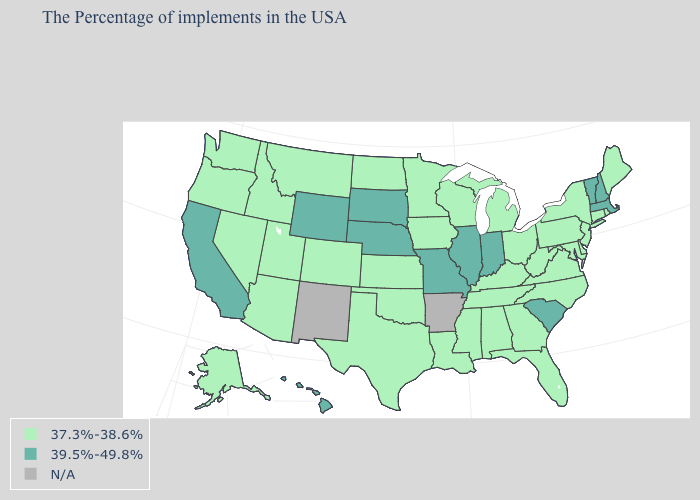Does the map have missing data?
Be succinct. Yes. Name the states that have a value in the range N/A?
Answer briefly. Arkansas, New Mexico. Among the states that border Vermont , does New Hampshire have the lowest value?
Concise answer only. No. Which states have the lowest value in the USA?
Be succinct. Maine, Rhode Island, Connecticut, New York, New Jersey, Delaware, Maryland, Pennsylvania, Virginia, North Carolina, West Virginia, Ohio, Florida, Georgia, Michigan, Kentucky, Alabama, Tennessee, Wisconsin, Mississippi, Louisiana, Minnesota, Iowa, Kansas, Oklahoma, Texas, North Dakota, Colorado, Utah, Montana, Arizona, Idaho, Nevada, Washington, Oregon, Alaska. Name the states that have a value in the range N/A?
Be succinct. Arkansas, New Mexico. What is the highest value in the South ?
Give a very brief answer. 39.5%-49.8%. What is the highest value in the USA?
Write a very short answer. 39.5%-49.8%. What is the value of New York?
Quick response, please. 37.3%-38.6%. What is the lowest value in the West?
Give a very brief answer. 37.3%-38.6%. What is the value of Delaware?
Keep it brief. 37.3%-38.6%. Which states have the highest value in the USA?
Concise answer only. Massachusetts, New Hampshire, Vermont, South Carolina, Indiana, Illinois, Missouri, Nebraska, South Dakota, Wyoming, California, Hawaii. How many symbols are there in the legend?
Give a very brief answer. 3. How many symbols are there in the legend?
Quick response, please. 3. Does Wyoming have the highest value in the USA?
Write a very short answer. Yes. 